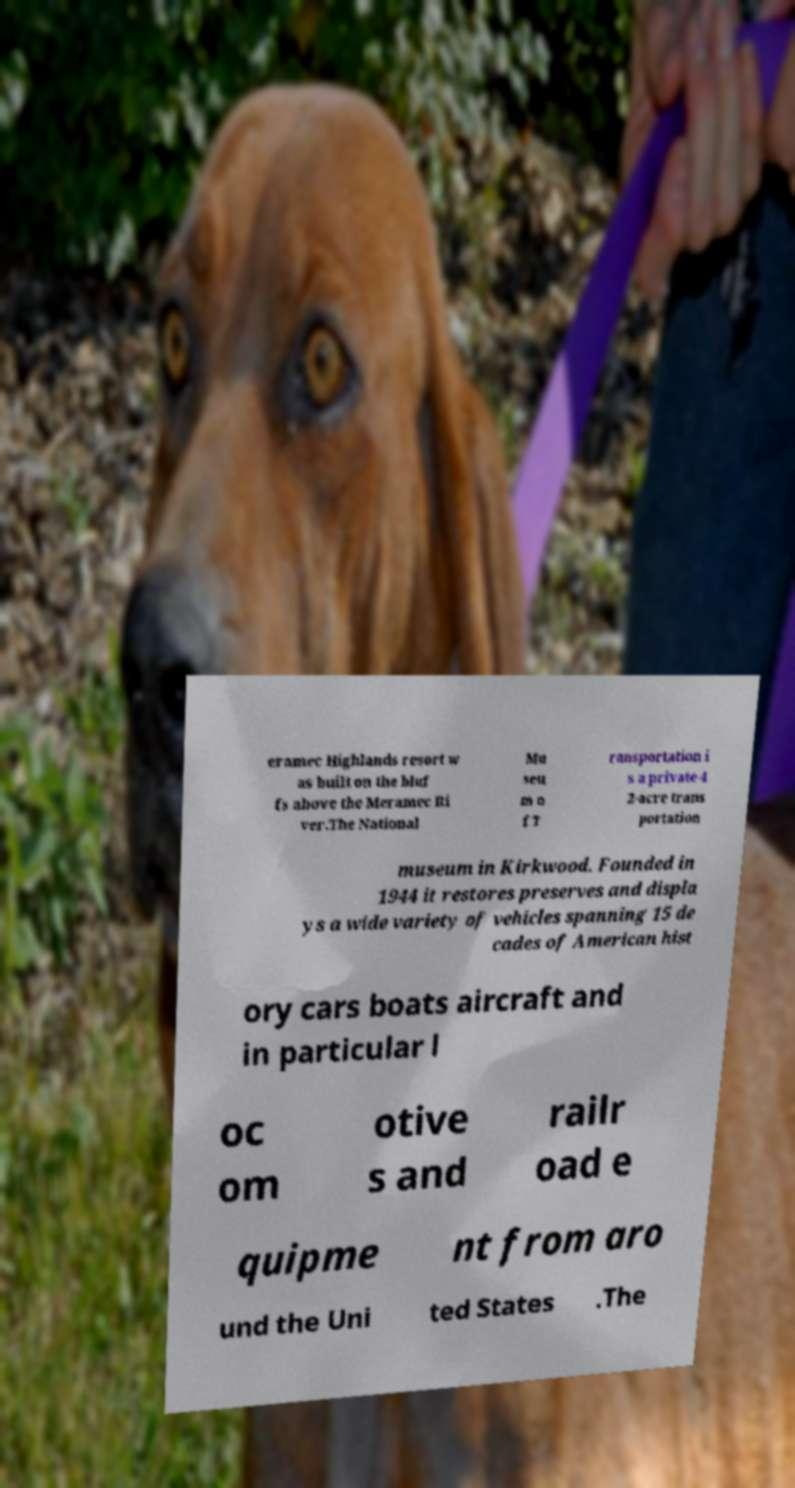Please identify and transcribe the text found in this image. eramec Highlands resort w as built on the bluf fs above the Meramec Ri ver.The National Mu seu m o f T ransportation i s a private 4 2-acre trans portation museum in Kirkwood. Founded in 1944 it restores preserves and displa ys a wide variety of vehicles spanning 15 de cades of American hist ory cars boats aircraft and in particular l oc om otive s and railr oad e quipme nt from aro und the Uni ted States .The 